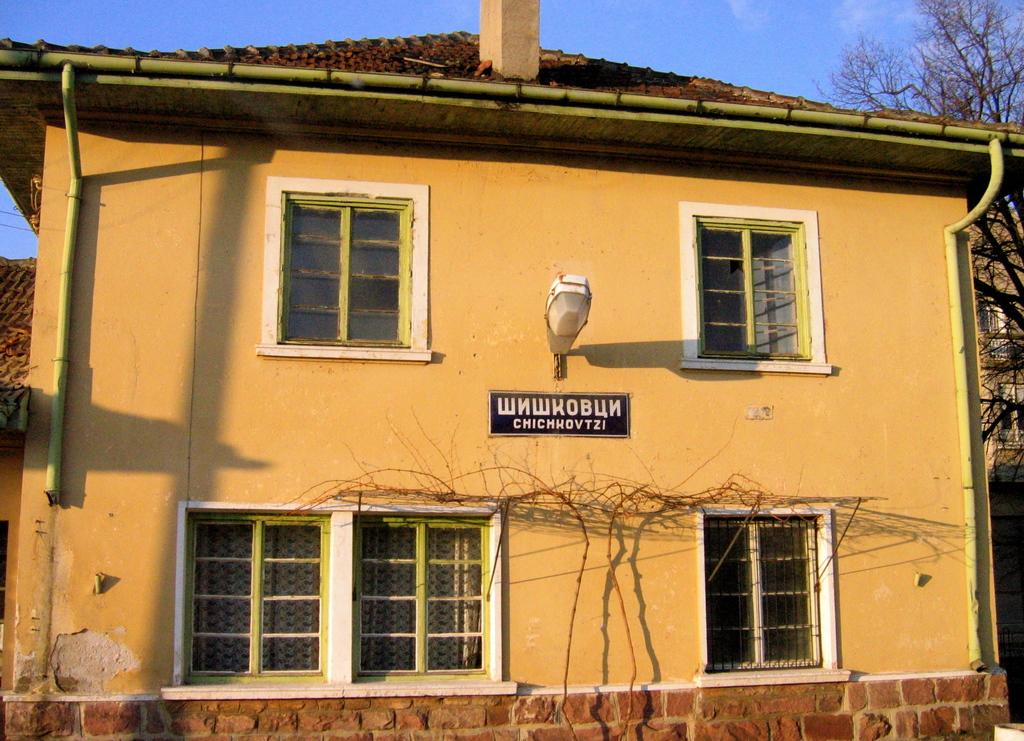Provide a one-sentence caption for the provided image. A building has a sign on it that is a foreign language. 